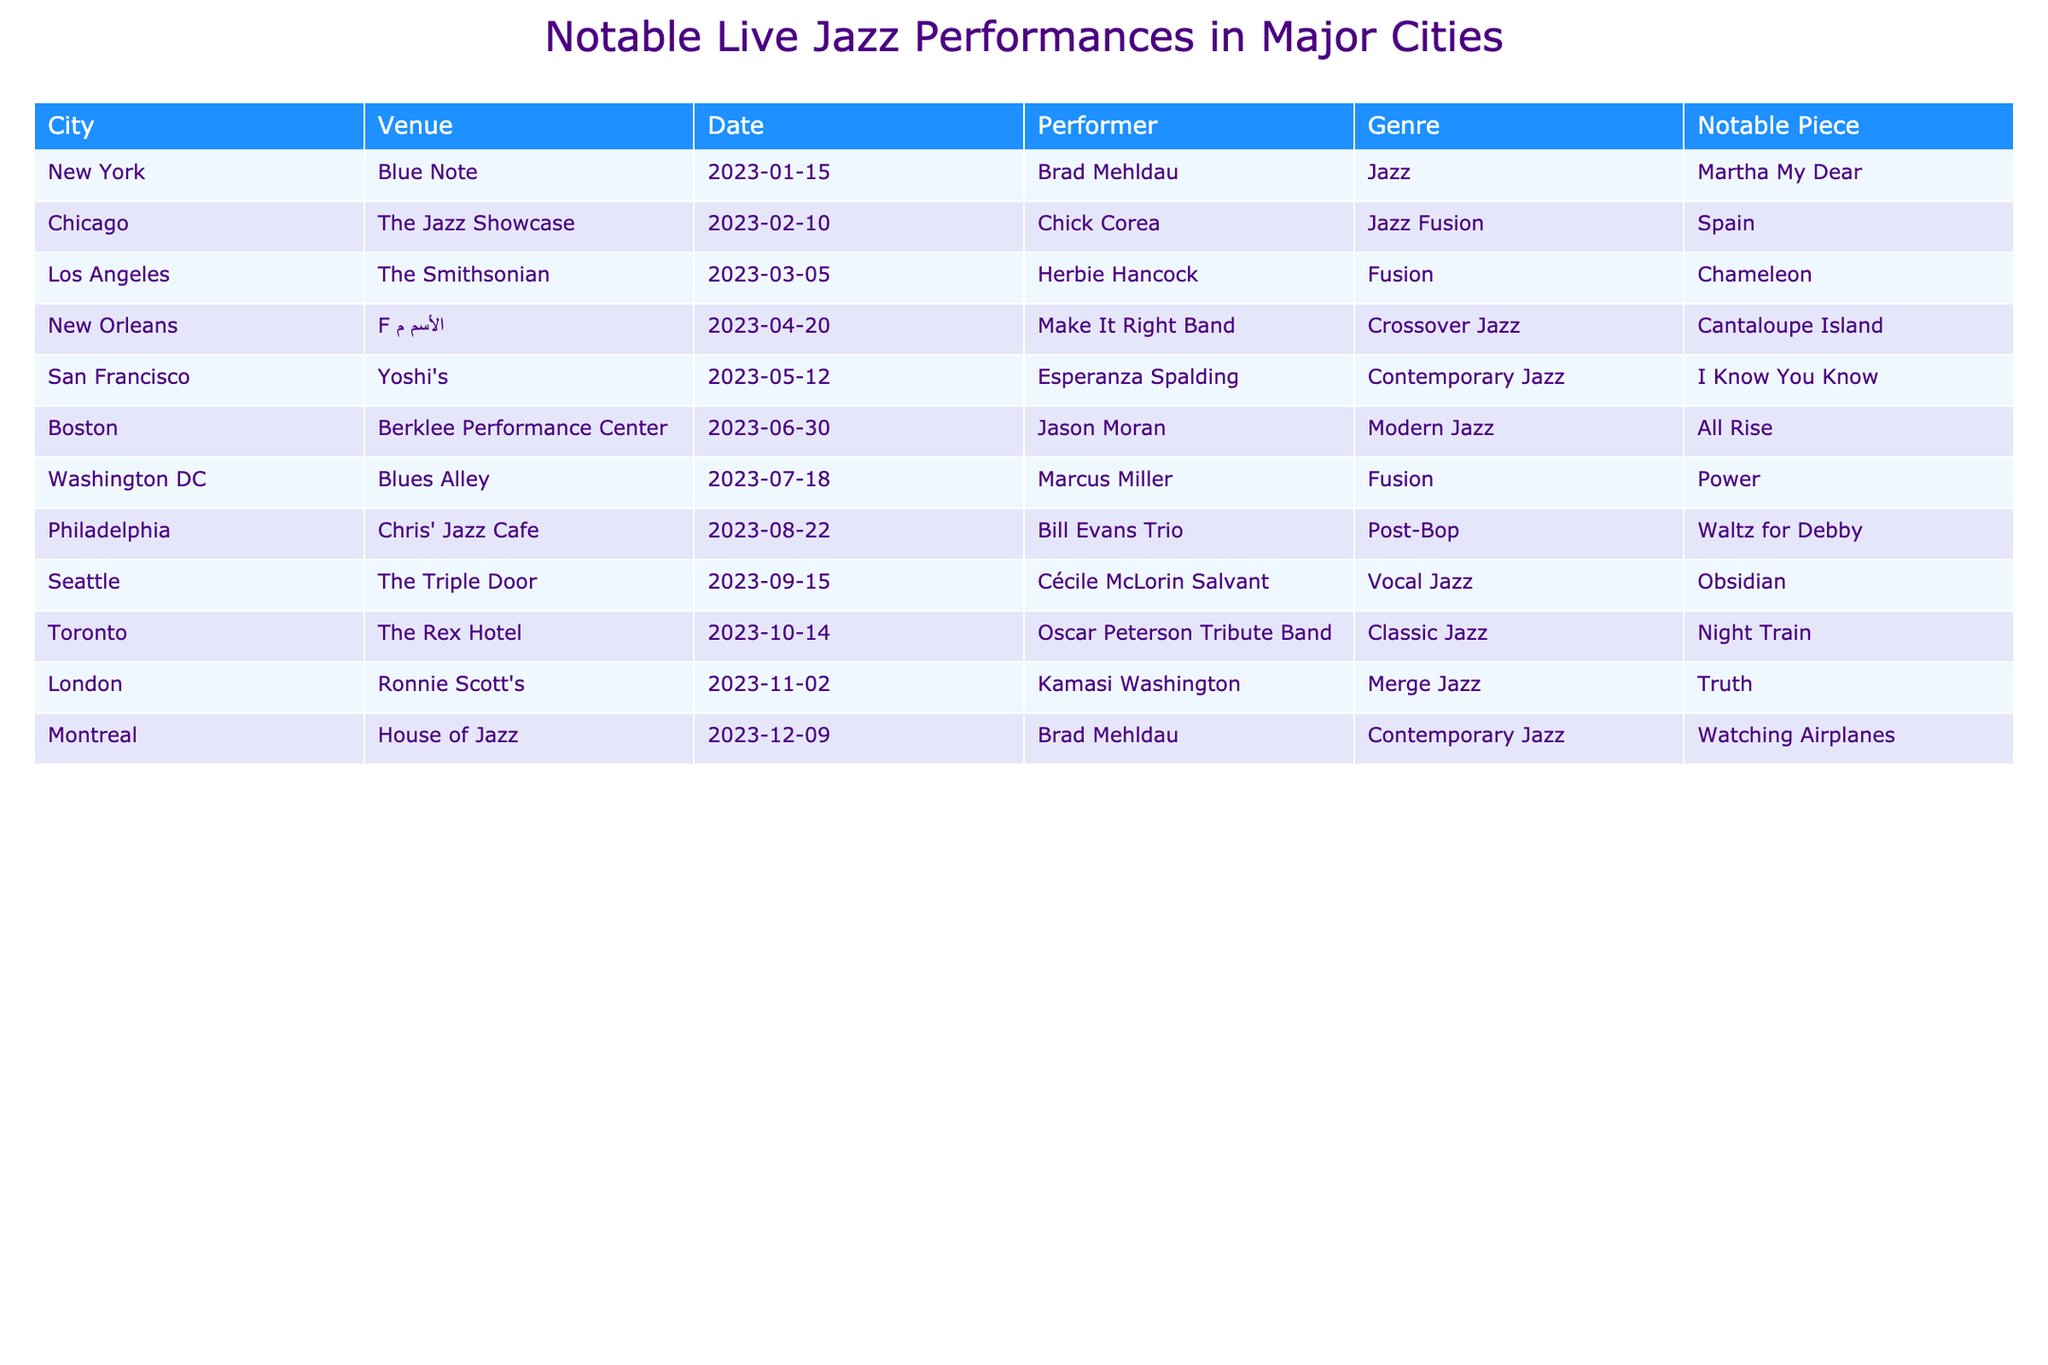What notable piece did Herbie Hancock perform in Los Angeles? The table lists Herbie Hancock as the performer in Los Angeles, specifically at The Smithsonian on March 5, 2023. The notable piece mentioned for this performance is "Chameleon."
Answer: Chameleon Which city hosted a live performance by Brad Mehldau? The table shows two instances of Brad Mehldau's performances: one in New York at Blue Note on January 15, 2023, and another in Montreal at House of Jazz on December 9, 2023.
Answer: New York and Montreal What is the total number of unique venues listed in the table? To determine the total number of unique venues, list all venues and ensure each is counted only once. The venues are Blue Note, The Jazz Showcase, The Smithsonian, F الأسم م, Yoshi's, Berklee Performance Center, Blues Alley, Chris' Jazz Cafe, The Triple Door, The Rex Hotel, Ronnie Scott's, and House of Jazz, totaling 12 unique venues.
Answer: 12 Did Chick Corea perform in New York? Referring to the table, Chick Corea is noted to have performed at The Jazz Showcase in Chicago on February 10, 2023, and there is no record of him performing in New York.
Answer: No Which performer had the most live performances listed in the table? Reviewing the table reveals that Brad Mehldau appears twice (once in New York and once in Montreal) while all other performers appear only once. Thus, Brad Mehldau has the most performances listed.
Answer: Brad Mehldau What genre did the Make It Right Band perform in New Orleans? According to the table, the Make It Right Band performed a crossover jazz genre in New Orleans at venue F الأسم م on April 20, 2023.
Answer: Crossover Jazz Which notable piece was performed in Boston? The table indicates that Jason Moran performed "All Rise" in Boston at Berklee Performance Center on June 30, 2023.
Answer: All Rise What was the date of the performance by Cécile McLorin Salvant in Seattle? The entry for Seattle lists Cécile McLorin Salvant performing at The Triple Door on September 15, 2023.
Answer: September 15, 2023 Which city had a performance featuring the Oscar Peterson Tribute Band? By examining the table, it shows that the Oscar Peterson Tribute Band performed in Toronto at The Rex Hotel on October 14, 2023.
Answer: Toronto 